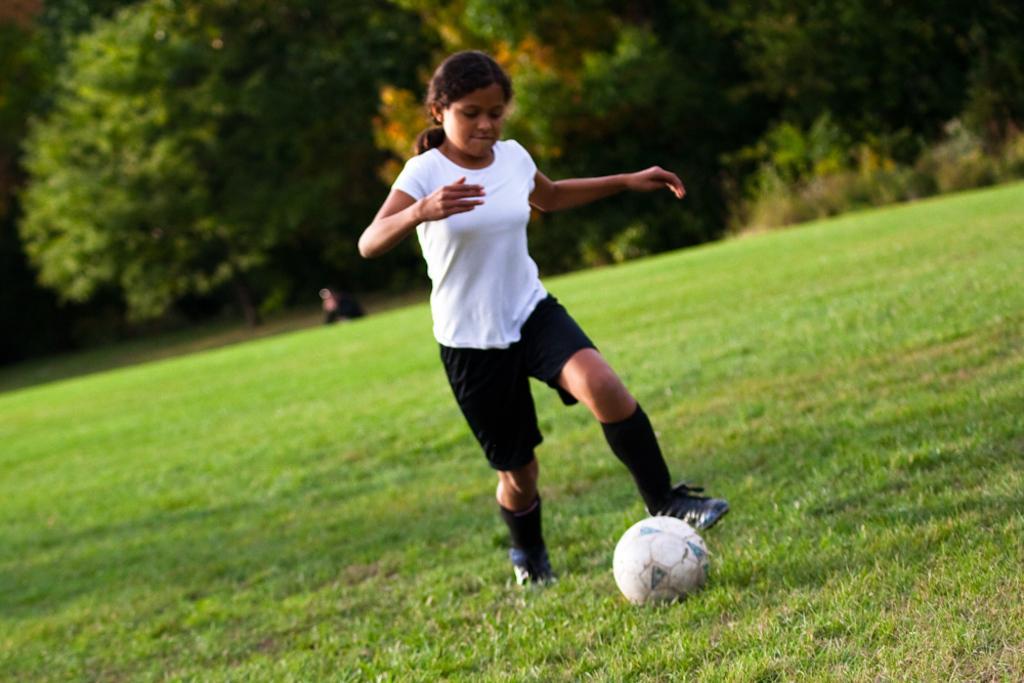Can you describe this image briefly? In this picture we can observe a girl wearing a white color T shirt and black color short, playing football in the ground. There is some grass on the ground. In the background there are trees. 